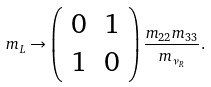Convert formula to latex. <formula><loc_0><loc_0><loc_500><loc_500>m _ { L } \rightarrow \left ( \begin{array} { c c c c } 0 & 1 \\ 1 & 0 \end{array} \right ) \frac { m _ { 2 2 } m _ { 3 3 } } { m _ { \nu _ { R } } } .</formula> 